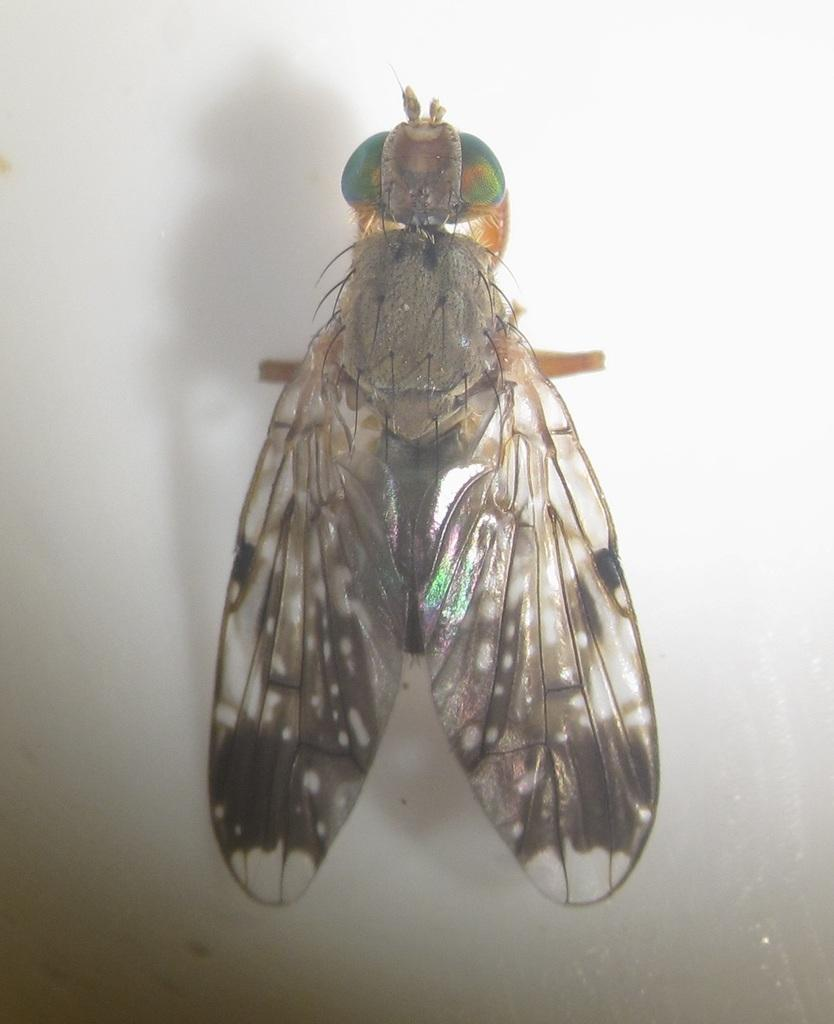What type of insect is present in the image? There is a housefly in the image. Where is the housefly located? The housefly is on a platform in the image. What type of toothbrush is the housefly using in the image? There is no toothbrush present in the image, and the housefly is not using any object. 